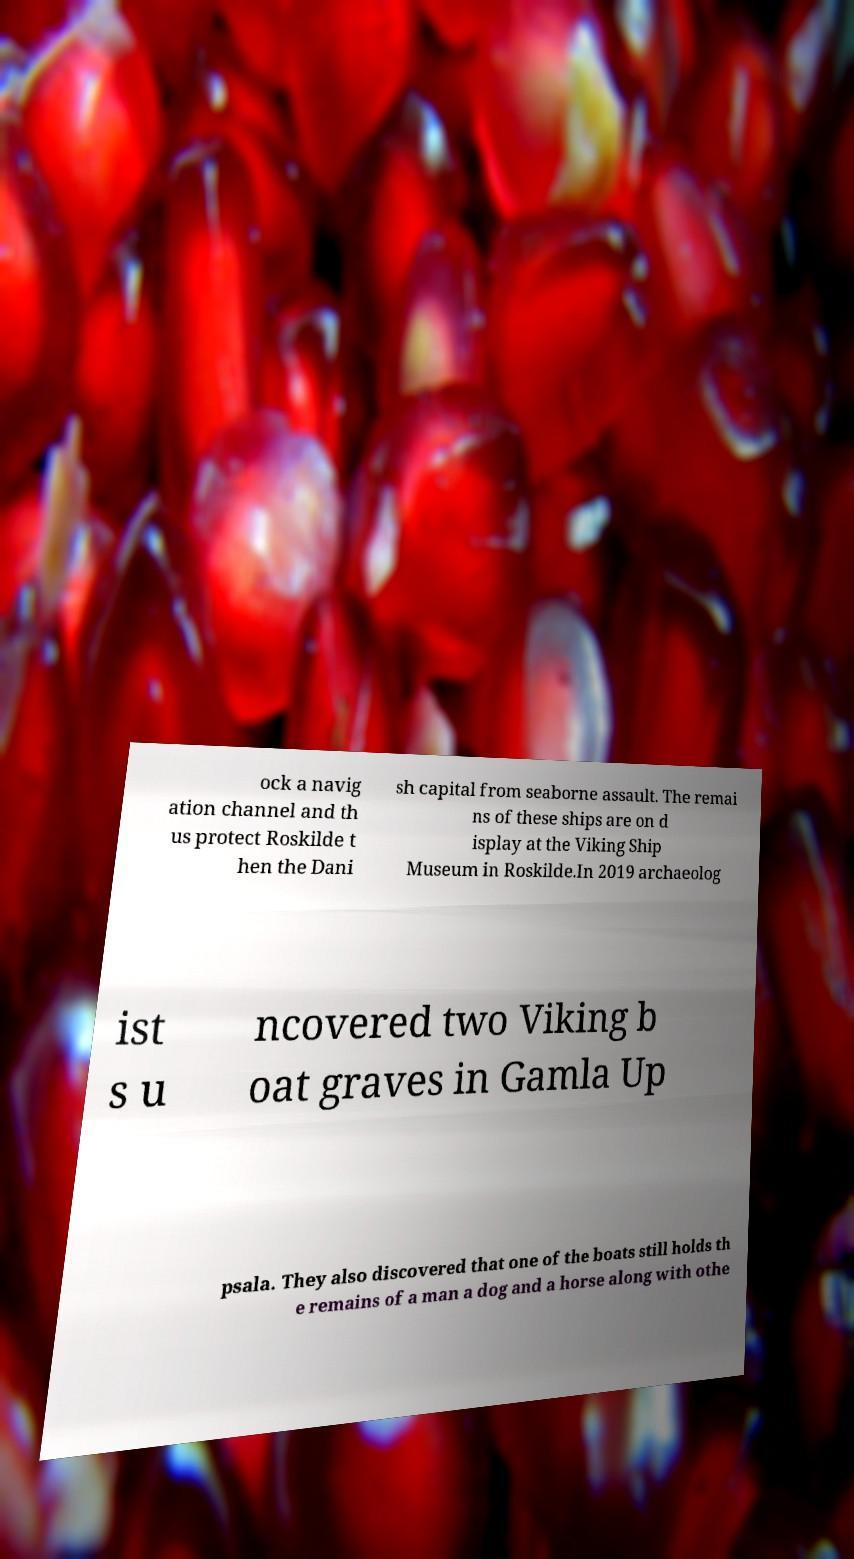Please read and relay the text visible in this image. What does it say? ock a navig ation channel and th us protect Roskilde t hen the Dani sh capital from seaborne assault. The remai ns of these ships are on d isplay at the Viking Ship Museum in Roskilde.In 2019 archaeolog ist s u ncovered two Viking b oat graves in Gamla Up psala. They also discovered that one of the boats still holds th e remains of a man a dog and a horse along with othe 